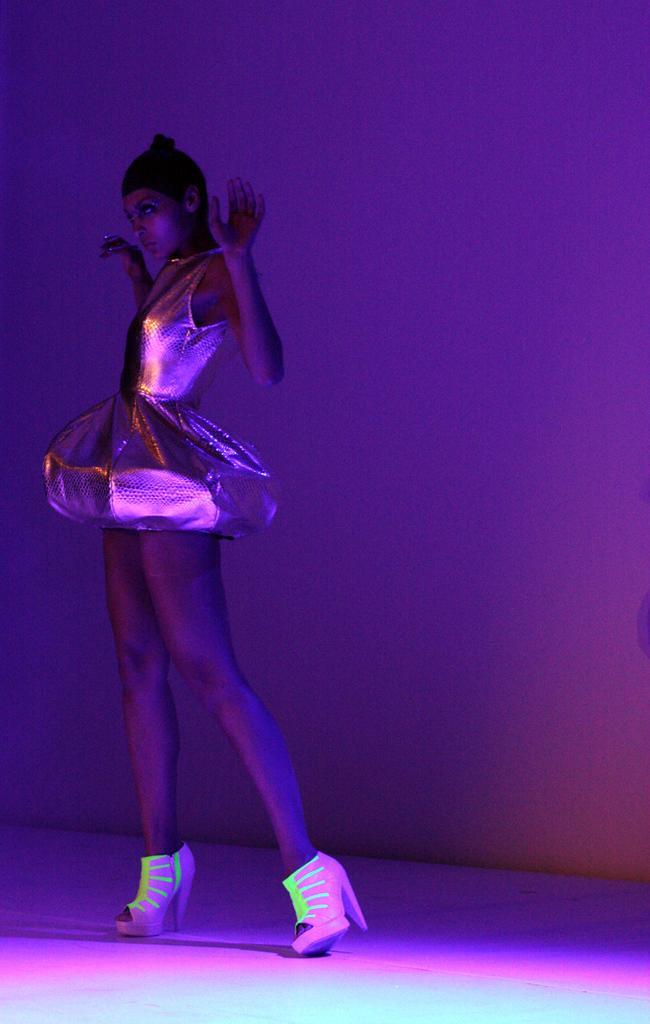Who is the main subject in the foreground of the image? There is a woman in the foreground of the image. What is the woman doing in the image? The woman is standing. What is the woman wearing in the image? The woman is wearing a frock and shoes. Where are the shoes located in the image? The shoes are on the surface. What colors of light can be seen on the wall in the background? There is a pink and violet light on the wall in the background. How does the woman react to the earthquake in the image? There is no indication of an earthquake in the image; the woman is simply standing and wearing a frock and shoes. What type of quince is being prepared in the image? There is no quince or any food preparation visible in the image. 